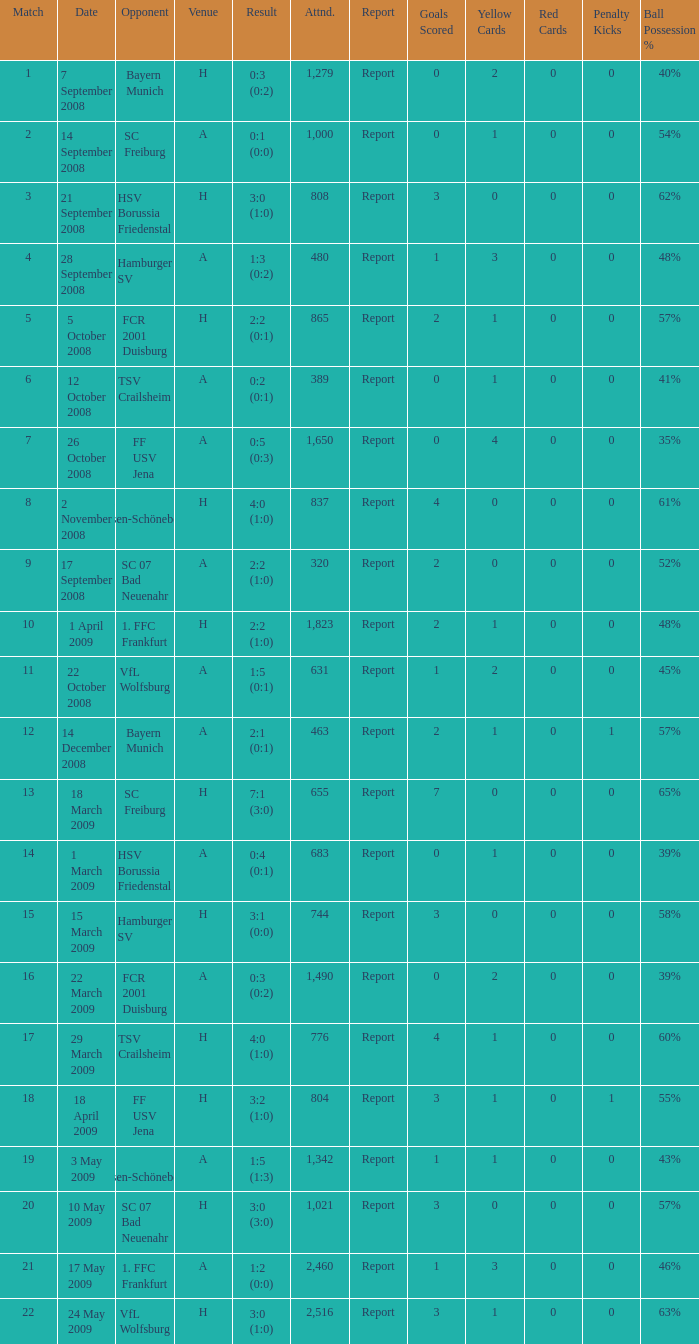Which match had more than 1,490 people in attendance to watch FCR 2001 Duisburg have a result of 0:3 (0:2)? None. 